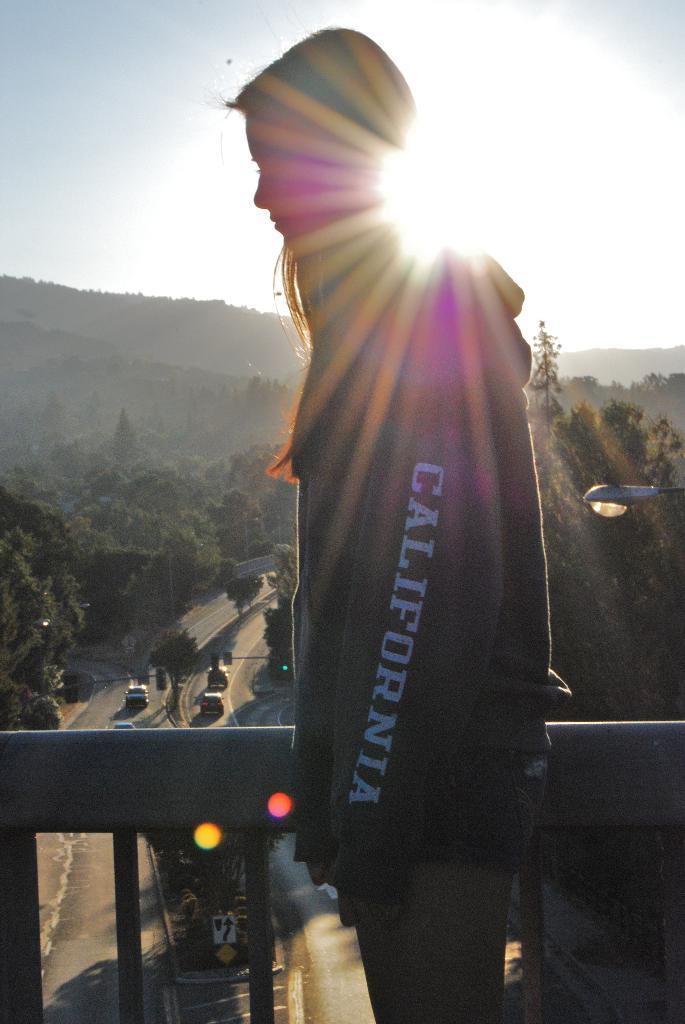Could you give a brief overview of what you see in this image? In this picture we can see vehicles on the road, trees, mountains, signboards, traffic signals, fence, light and a girl wore a cap and standing and in the background we can see the sky. 